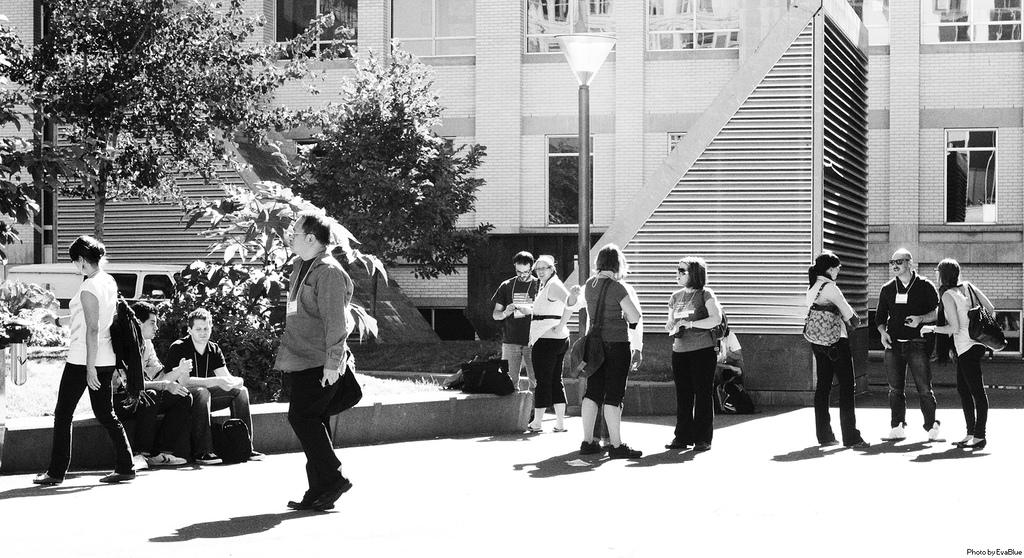What is the color scheme of the image? The image is black and white. What type of structure can be seen in the image? There is a building in the image. What natural elements are present in the image? There are trees in the image. What architectural features can be observed in the building? There are windows and shutters in the image. What are the people in the image doing? There are people in the image, but their actions are not specified. What objects are being carried by the people? There are bags in the image. What vertical object is present in the image? There is a pole in the image. What source of illumination is visible in the image? There is a light in the image. What mode of transportation is present in the image? There is a vehicle in the image. What type of verse can be heard recited by the apparatus in the image? There is no apparatus present in the image, and therefore no verse can be heard. 